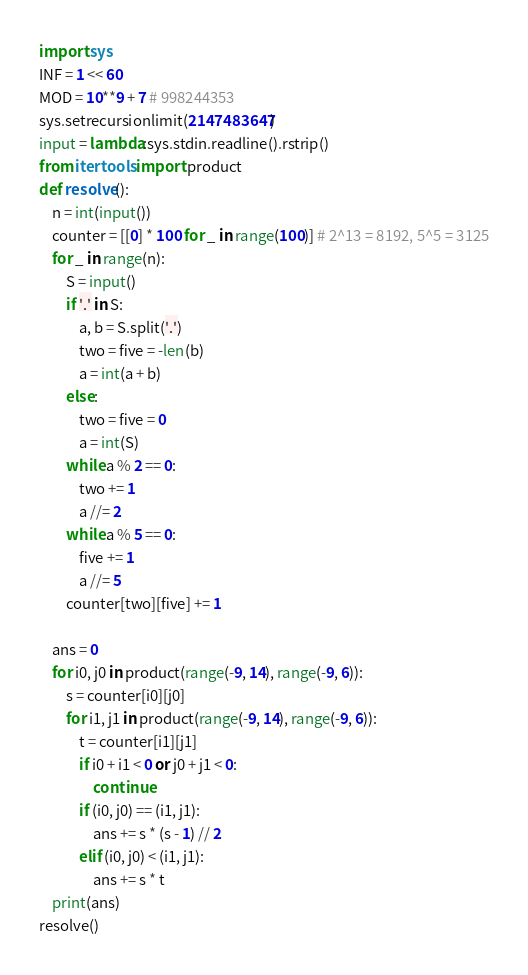<code> <loc_0><loc_0><loc_500><loc_500><_Python_>import sys
INF = 1 << 60
MOD = 10**9 + 7 # 998244353
sys.setrecursionlimit(2147483647)
input = lambda:sys.stdin.readline().rstrip()
from itertools import product
def resolve():
    n = int(input())
    counter = [[0] * 100 for _ in range(100)] # 2^13 = 8192, 5^5 = 3125
    for _ in range(n):
        S = input()
        if '.' in S:
            a, b = S.split('.')
            two = five = -len(b)
            a = int(a + b)
        else:
            two = five = 0
            a = int(S)
        while a % 2 == 0:
            two += 1
            a //= 2
        while a % 5 == 0:
            five += 1
            a //= 5
        counter[two][five] += 1

    ans = 0
    for i0, j0 in product(range(-9, 14), range(-9, 6)):
        s = counter[i0][j0]
        for i1, j1 in product(range(-9, 14), range(-9, 6)):
            t = counter[i1][j1]
            if i0 + i1 < 0 or j0 + j1 < 0:
                continue
            if (i0, j0) == (i1, j1):
                ans += s * (s - 1) // 2
            elif (i0, j0) < (i1, j1):
                ans += s * t
    print(ans)
resolve()</code> 